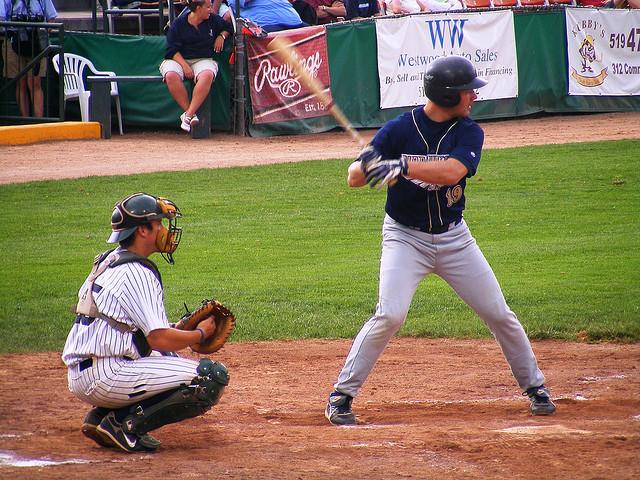Is there an umpire?
Be succinct. No. What color is the batters shirt?
Give a very brief answer. Blue. Which parts of the catcher's body are most likely to get cramped in that position?
Be succinct. Legs. Is there dirt on the batter's uniform?
Give a very brief answer. No. What color is the batters uniform?
Quick response, please. Blue. How can you tell the boy has been sitting down?
Quick response, please. Can't. What number does the battery have on?
Give a very brief answer. 19. What is the batter's name?
Be succinct. John. What position does this boy play?
Write a very short answer. Catcher. 